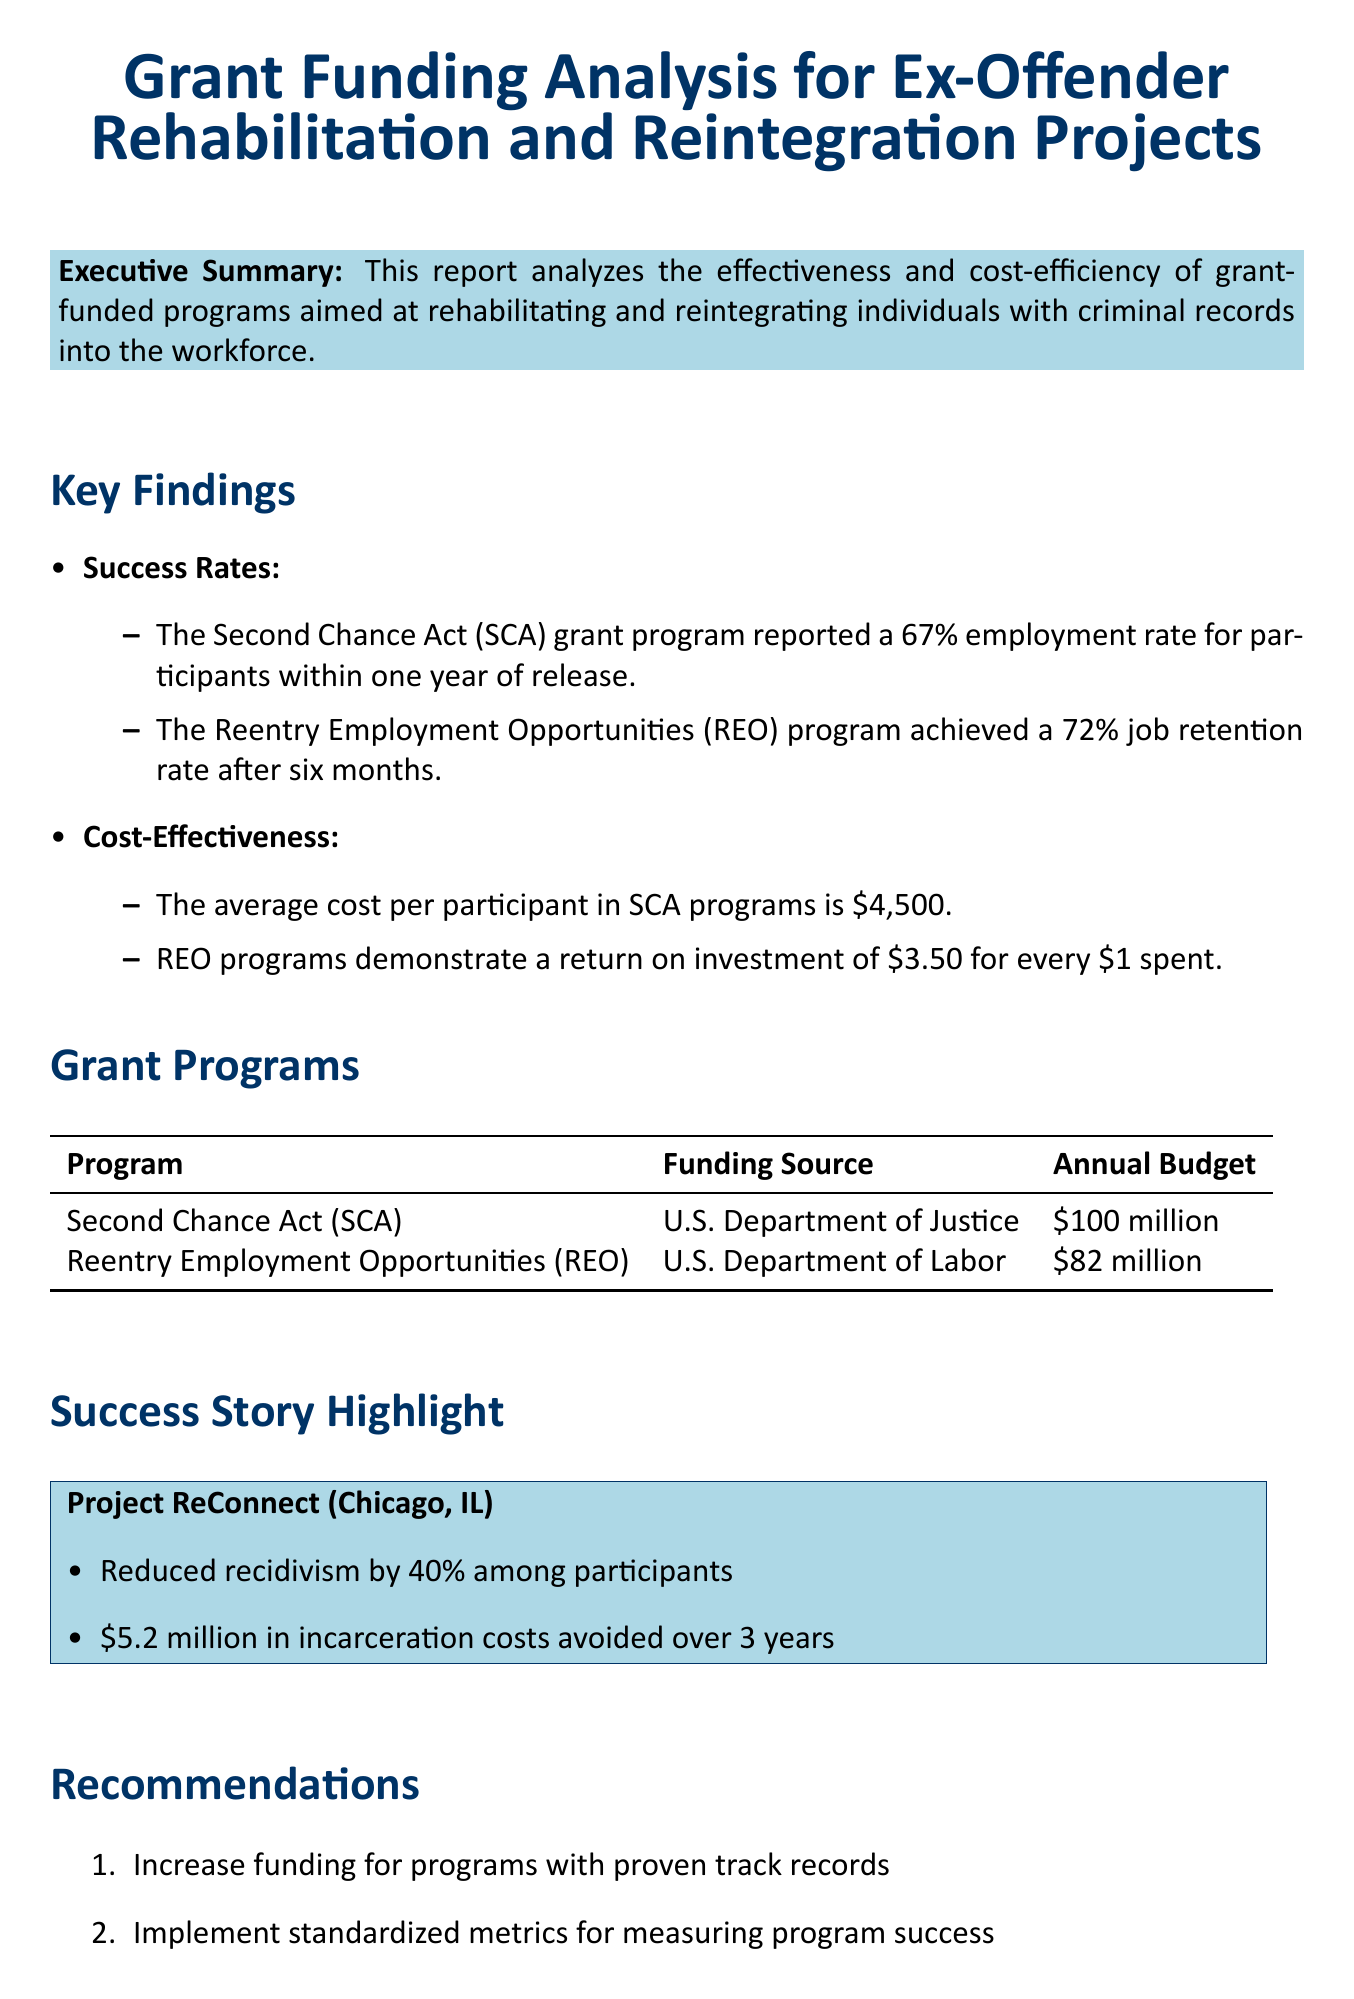What is the employment rate reported for the Second Chance Act program? The document states that the Second Chance Act grant program reported a 67% employment rate for participants within one year of release.
Answer: 67% What is the job retention rate for the Reentry Employment Opportunities program? According to the report, the Reentry Employment Opportunities program achieved a 72% job retention rate after six months.
Answer: 72% What is the average cost per participant in SCA programs? The report specifies that the average cost per participant in SCA programs is $4,500.
Answer: $4,500 How much does the REO program return for every dollar spent? The document indicates that REO programs demonstrate a return on investment of $3.50 for every $1 spent.
Answer: $3.50 What was the recidivism reduction percentage for Project ReConnect? The success story in the document notes that Project ReConnect reduced recidivism by 40% among participants.
Answer: 40% What is the annual budget for the Second Chance Act? The report states that the annual budget for the Second Chance Act is $100 million.
Answer: $100 million What focus area is common between the SCA and REO programs? The document highlights employment assistance as a focus area for the SCA program, while the REO program focuses on job training, which relates to employment.
Answer: Employment What is one recommendation made in the report? The document includes multiple recommendations; one is to increase funding for programs with proven track records.
Answer: Increase funding for programs with proven track records 